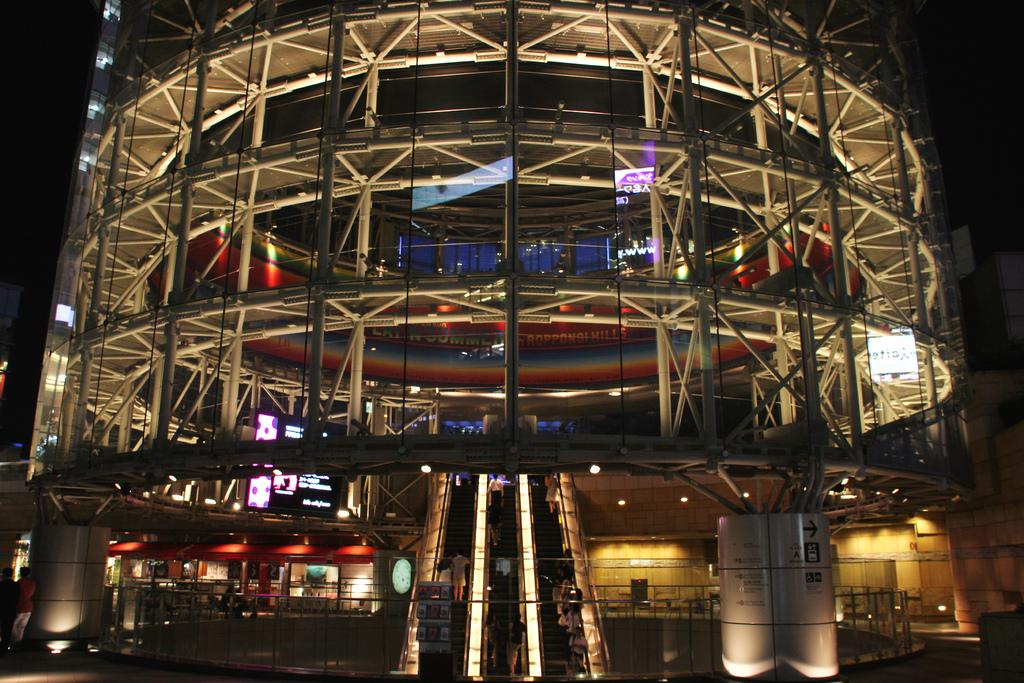What type of structure is visible in the image? There is a building in the image. What features can be seen on the building? The building has projector screens, banners, lights, and an escalator. How does the building make payments to its employees? The image does not provide information about the building's payment methods to its employees. --- Facts: 1. There is a person in the image. 2. The person is holding a book. 3. The person is sitting on a chair. 4. The chair has wheels. 5. The background of the image is a library. Absurd Topics: animal, ocean, mountain Conversation: What is the person in the image doing? The person in the image is holding a book. Where is the person sitting? The person is sitting on a chair. What type of chair is the person sitting on? The chair has wheels. What can be seen in the background of the image? The background of the image is a library. Reasoning: Let's think step by step in order to produce the conversation. We start by identifying the main subject in the image, which is the person. Then, we describe what the person is doing, which is holding a book. Next, we expand the conversation to include the chair the person is sitting on, noting that it has wheels. Finally, we describe the background of the image, which is a library. Absurd Question/Answer: What type of animal can be seen swimming in the ocean in the image? There is no animal swimming in the ocean in the image; it is set in a library. 